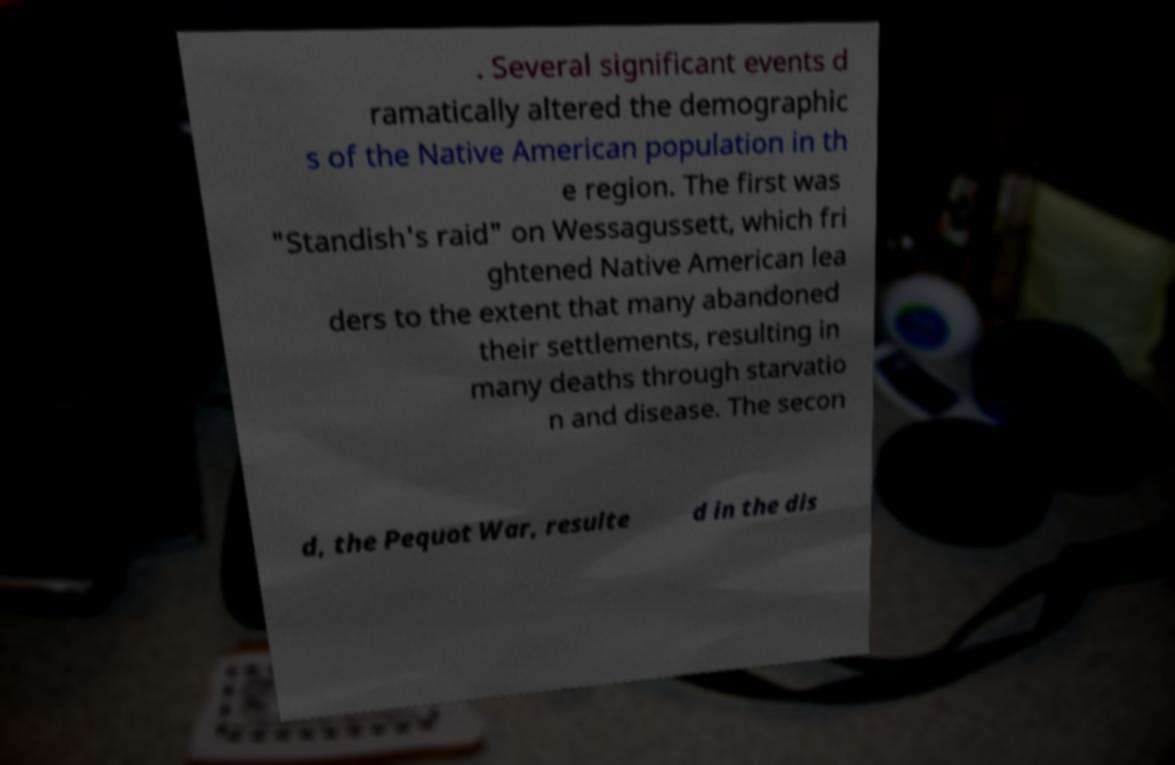There's text embedded in this image that I need extracted. Can you transcribe it verbatim? . Several significant events d ramatically altered the demographic s of the Native American population in th e region. The first was "Standish's raid" on Wessagussett, which fri ghtened Native American lea ders to the extent that many abandoned their settlements, resulting in many deaths through starvatio n and disease. The secon d, the Pequot War, resulte d in the dis 